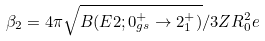<formula> <loc_0><loc_0><loc_500><loc_500>\beta _ { 2 } = 4 \pi \sqrt { B ( E 2 ; 0 ^ { + } _ { g s } \rightarrow 2 ^ { + } _ { 1 } ) } / 3 Z R _ { 0 } ^ { 2 } e</formula> 